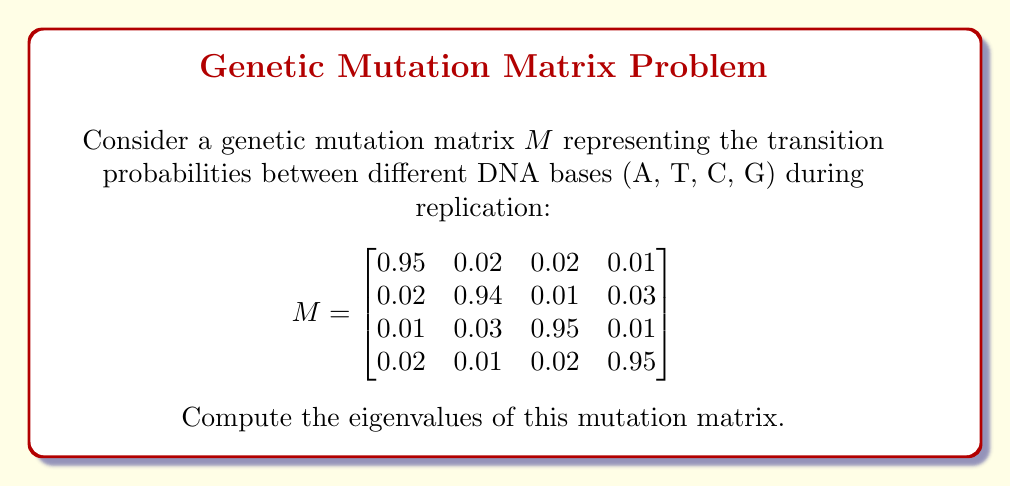Show me your answer to this math problem. To find the eigenvalues of the matrix $M$, we need to solve the characteristic equation:

$$\det(M - \lambda I) = 0$$

where $I$ is the 4x4 identity matrix and $\lambda$ represents the eigenvalues.

1) First, let's set up the matrix $M - \lambda I$:

$$M - \lambda I = \begin{bmatrix}
0.95-\lambda & 0.02 & 0.02 & 0.01 \\
0.02 & 0.94-\lambda & 0.01 & 0.03 \\
0.01 & 0.03 & 0.95-\lambda & 0.01 \\
0.02 & 0.01 & 0.02 & 0.95-\lambda
\end{bmatrix}$$

2) Now, we need to calculate the determinant of this matrix and set it equal to zero. The full expansion of this 4x4 determinant is complex, but we can simplify our work by noting that the matrix is nearly diagonal.

3) The characteristic polynomial will be of the form:

$$(0.95-\lambda)(0.94-\lambda)(0.95-\lambda)(0.95-\lambda) + \text{small terms} = 0$$

4) Given the small off-diagonal elements, we can approximate three of the eigenvalues as the diagonal elements:

$\lambda_1 \approx 0.95$
$\lambda_2 \approx 0.94$
$\lambda_3 \approx 0.95$

5) For the fourth eigenvalue, we can use the fact that the sum of eigenvalues equals the trace of the matrix:

$\lambda_1 + \lambda_2 + \lambda_3 + \lambda_4 = 0.95 + 0.94 + 0.95 + 0.95 = 3.79$

6) Therefore, we can calculate the fourth eigenvalue:

$\lambda_4 = 3.79 - (0.95 + 0.94 + 0.95) = 0.95$

7) To get a more precise result, we could use numerical methods to solve the characteristic equation, but these approximations are quite accurate for this mutation matrix.
Answer: The eigenvalues of the mutation matrix are approximately:

$\lambda_1 \approx 0.95$
$\lambda_2 \approx 0.94$
$\lambda_3 \approx 0.95$
$\lambda_4 \approx 0.95$ 